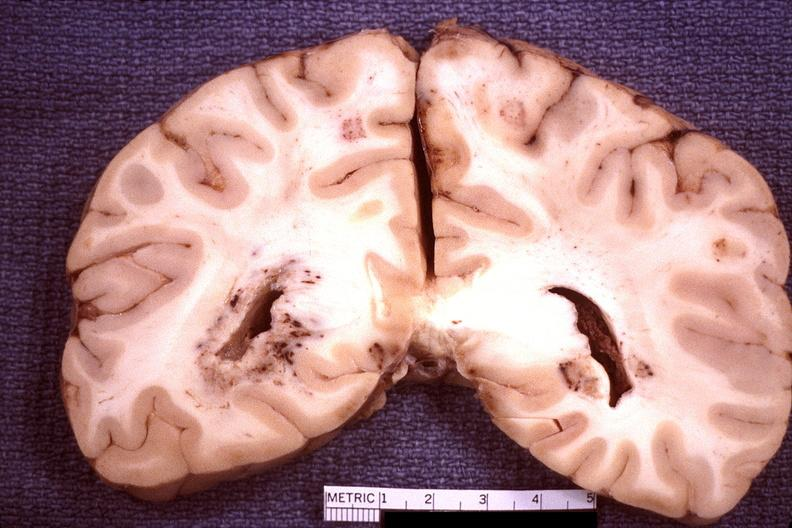does histoplasmosis show brain, toxoplasma encephalitis?
Answer the question using a single word or phrase. No 